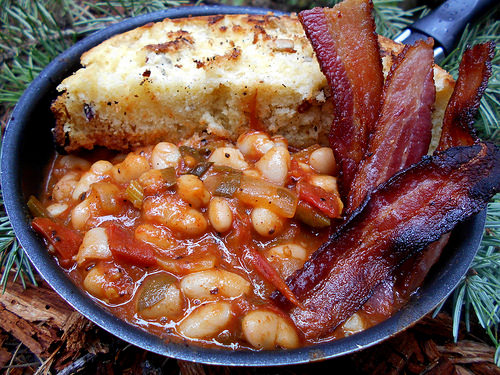<image>
Can you confirm if the bacon is next to the beans? No. The bacon is not positioned next to the beans. They are located in different areas of the scene. Where is the bacon in relation to the soup? Is it to the right of the soup? Yes. From this viewpoint, the bacon is positioned to the right side relative to the soup. 